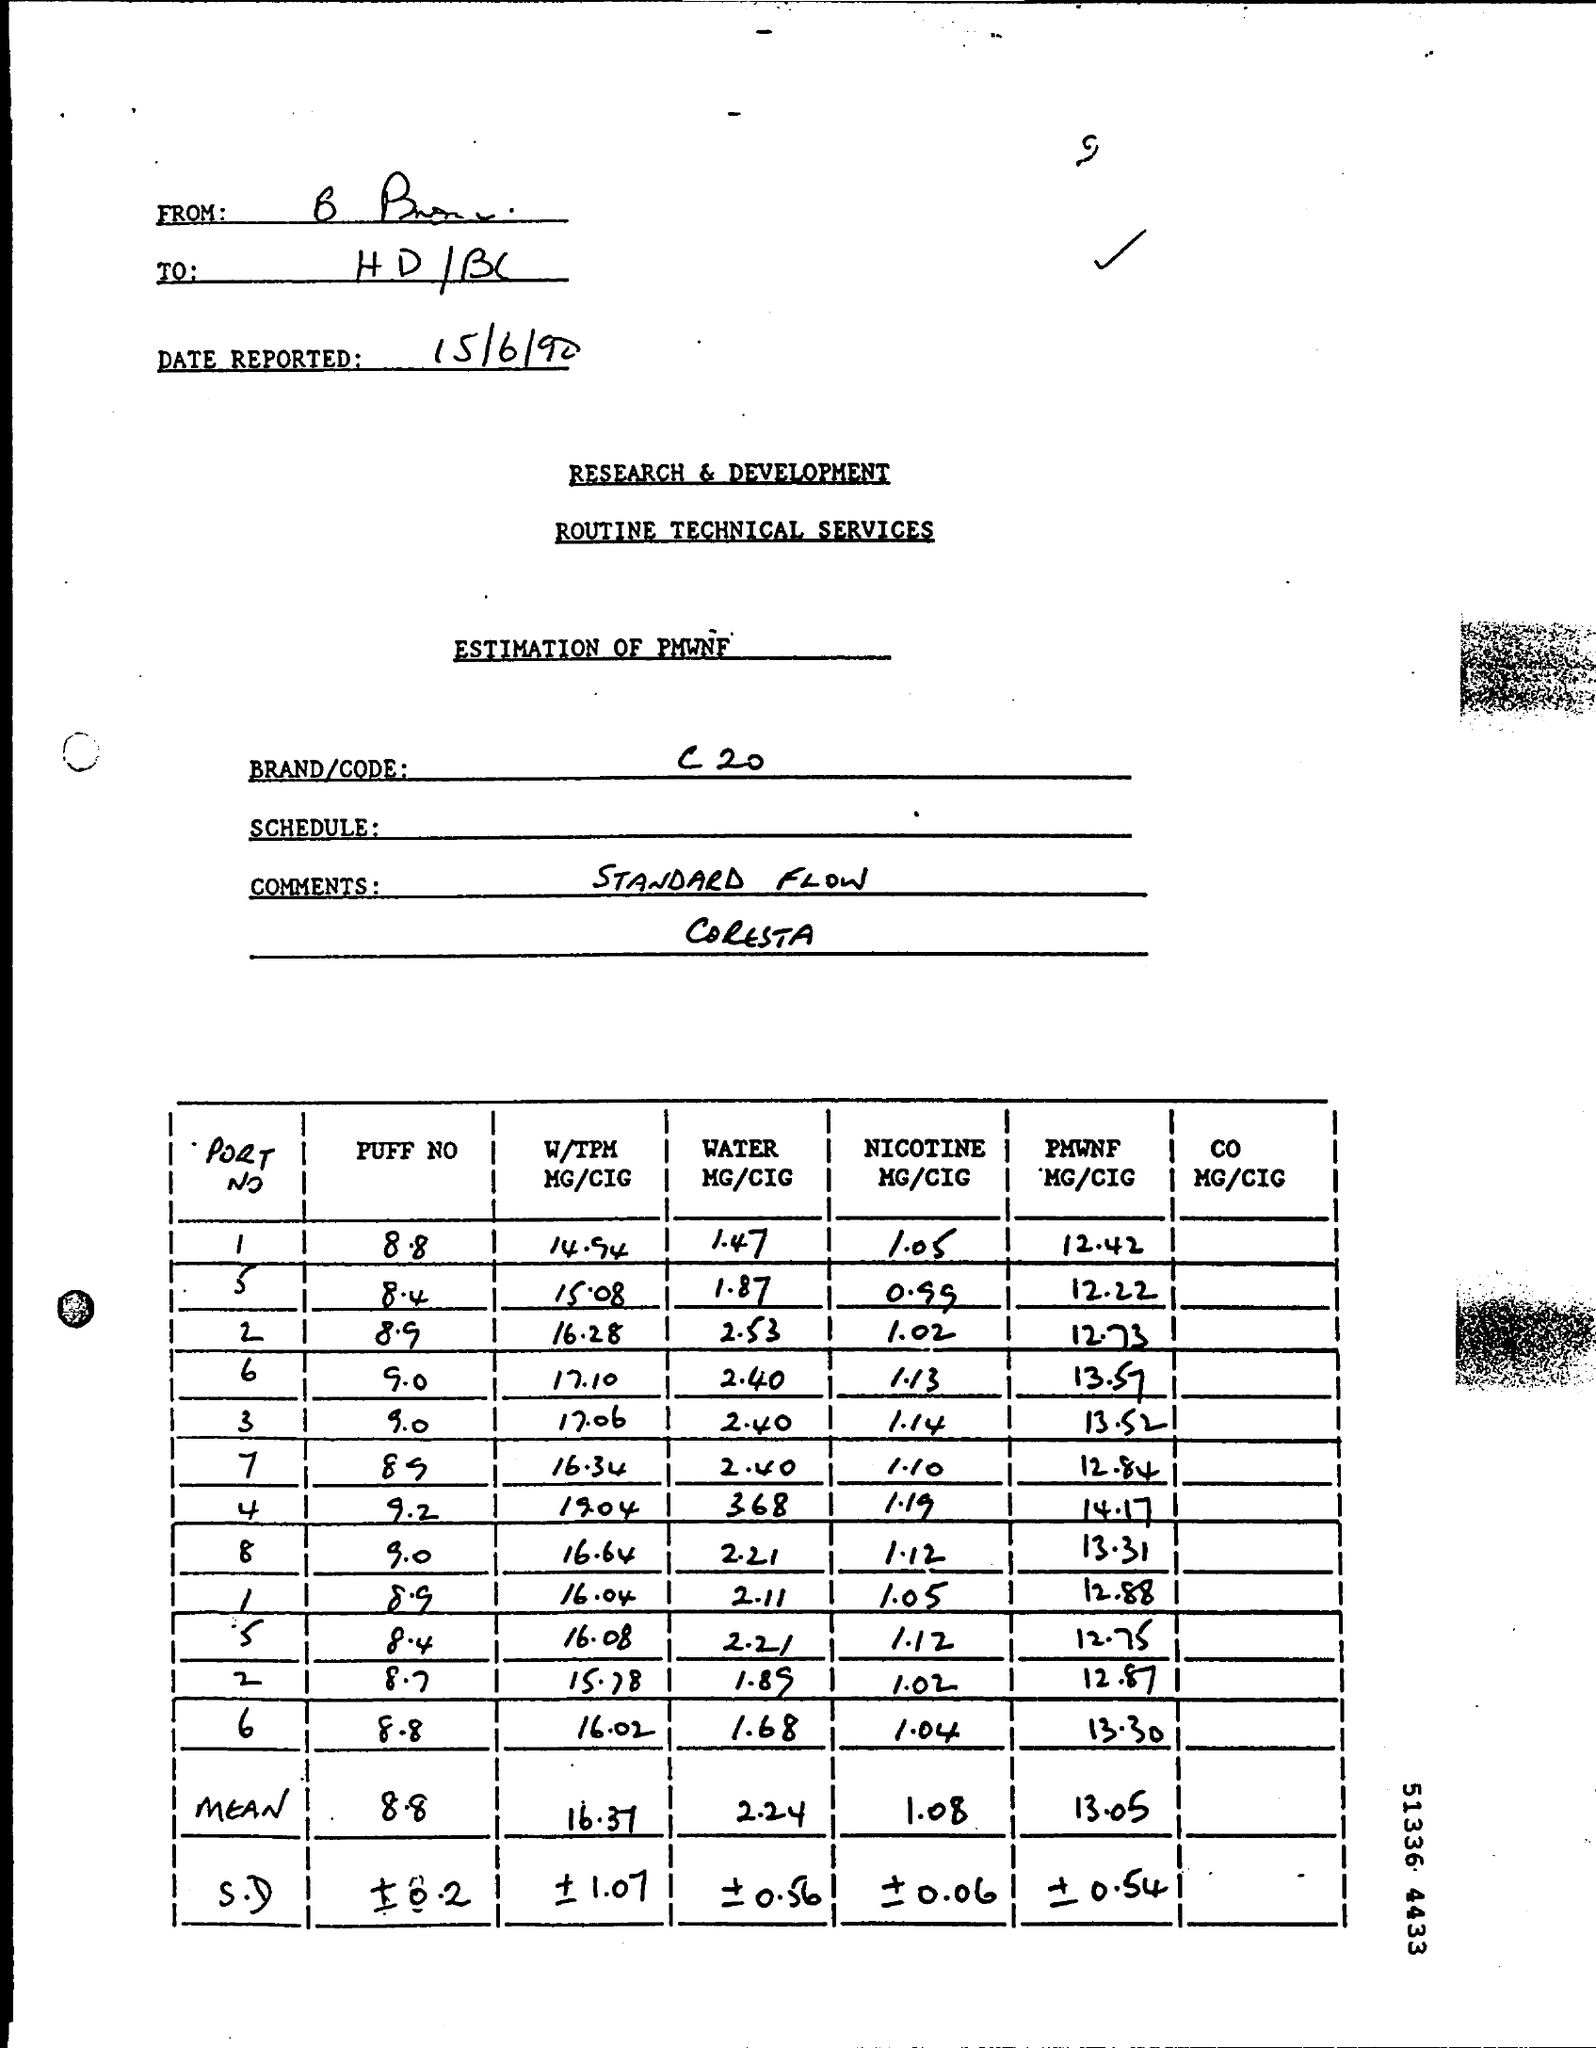List a handful of essential elements in this visual. The BRAND/CODE field contains the information C20. 